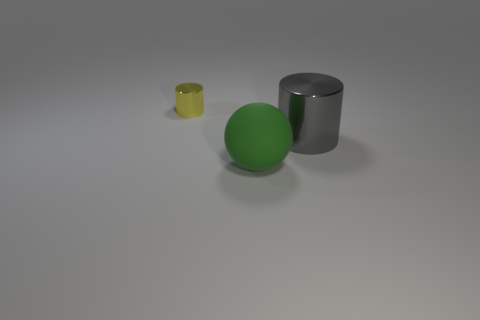What color is the large object on the right side of the large matte thing?
Provide a short and direct response. Gray. There is a cylinder that is to the right of the large green thing; are there any yellow things that are behind it?
Provide a succinct answer. Yes. What number of things are metal things left of the green rubber thing or blue spheres?
Offer a terse response. 1. Are there any other things that have the same size as the yellow cylinder?
Provide a short and direct response. No. There is a cylinder that is behind the big thing behind the large green rubber thing; what is its material?
Provide a short and direct response. Metal. Is the number of large objects that are left of the green ball the same as the number of big balls that are behind the small shiny cylinder?
Provide a succinct answer. Yes. How many things are either things that are behind the green sphere or shiny objects that are behind the big metal thing?
Provide a short and direct response. 2. What material is the object that is behind the big green matte sphere and to the right of the small yellow metal cylinder?
Ensure brevity in your answer.  Metal. There is a metal object that is in front of the shiny object behind the large object that is on the right side of the large green object; what size is it?
Your answer should be very brief. Large. Is the number of rubber things greater than the number of shiny objects?
Your response must be concise. No. 